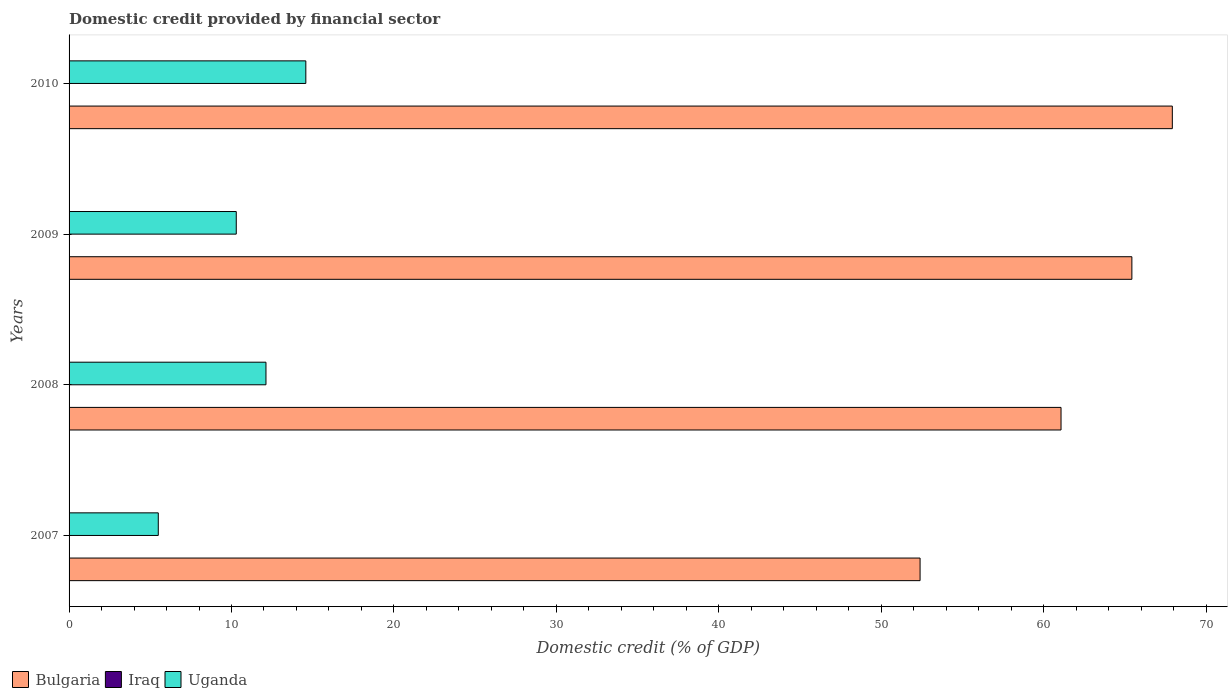How many different coloured bars are there?
Provide a short and direct response. 2. How many groups of bars are there?
Your answer should be compact. 4. Are the number of bars on each tick of the Y-axis equal?
Your response must be concise. Yes. What is the domestic credit in Iraq in 2009?
Ensure brevity in your answer.  0. Across all years, what is the maximum domestic credit in Bulgaria?
Offer a terse response. 67.92. Across all years, what is the minimum domestic credit in Uganda?
Offer a terse response. 5.49. In which year was the domestic credit in Bulgaria maximum?
Keep it short and to the point. 2010. What is the total domestic credit in Bulgaria in the graph?
Offer a terse response. 246.82. What is the difference between the domestic credit in Bulgaria in 2008 and that in 2009?
Keep it short and to the point. -4.36. What is the difference between the domestic credit in Uganda in 2010 and the domestic credit in Iraq in 2007?
Offer a terse response. 14.58. In the year 2009, what is the difference between the domestic credit in Uganda and domestic credit in Bulgaria?
Provide a succinct answer. -55.14. What is the ratio of the domestic credit in Uganda in 2008 to that in 2009?
Ensure brevity in your answer.  1.18. Is the domestic credit in Bulgaria in 2007 less than that in 2008?
Provide a short and direct response. Yes. Is the difference between the domestic credit in Uganda in 2007 and 2010 greater than the difference between the domestic credit in Bulgaria in 2007 and 2010?
Offer a terse response. Yes. What is the difference between the highest and the second highest domestic credit in Bulgaria?
Your answer should be compact. 2.49. What is the difference between the highest and the lowest domestic credit in Uganda?
Your answer should be very brief. 9.08. How many bars are there?
Your answer should be very brief. 8. How many years are there in the graph?
Ensure brevity in your answer.  4. Are the values on the major ticks of X-axis written in scientific E-notation?
Offer a terse response. No. Does the graph contain any zero values?
Make the answer very short. Yes. How many legend labels are there?
Your response must be concise. 3. What is the title of the graph?
Offer a terse response. Domestic credit provided by financial sector. Does "Qatar" appear as one of the legend labels in the graph?
Your response must be concise. No. What is the label or title of the X-axis?
Provide a short and direct response. Domestic credit (% of GDP). What is the label or title of the Y-axis?
Your response must be concise. Years. What is the Domestic credit (% of GDP) in Bulgaria in 2007?
Offer a terse response. 52.39. What is the Domestic credit (% of GDP) of Iraq in 2007?
Offer a very short reply. 0. What is the Domestic credit (% of GDP) in Uganda in 2007?
Provide a short and direct response. 5.49. What is the Domestic credit (% of GDP) in Bulgaria in 2008?
Your response must be concise. 61.07. What is the Domestic credit (% of GDP) in Uganda in 2008?
Keep it short and to the point. 12.12. What is the Domestic credit (% of GDP) of Bulgaria in 2009?
Offer a terse response. 65.43. What is the Domestic credit (% of GDP) in Iraq in 2009?
Your response must be concise. 0. What is the Domestic credit (% of GDP) of Uganda in 2009?
Offer a very short reply. 10.29. What is the Domestic credit (% of GDP) in Bulgaria in 2010?
Offer a very short reply. 67.92. What is the Domestic credit (% of GDP) of Uganda in 2010?
Make the answer very short. 14.58. Across all years, what is the maximum Domestic credit (% of GDP) in Bulgaria?
Your answer should be compact. 67.92. Across all years, what is the maximum Domestic credit (% of GDP) of Uganda?
Make the answer very short. 14.58. Across all years, what is the minimum Domestic credit (% of GDP) in Bulgaria?
Provide a succinct answer. 52.39. Across all years, what is the minimum Domestic credit (% of GDP) in Uganda?
Ensure brevity in your answer.  5.49. What is the total Domestic credit (% of GDP) of Bulgaria in the graph?
Your response must be concise. 246.82. What is the total Domestic credit (% of GDP) in Uganda in the graph?
Your answer should be very brief. 42.48. What is the difference between the Domestic credit (% of GDP) in Bulgaria in 2007 and that in 2008?
Keep it short and to the point. -8.68. What is the difference between the Domestic credit (% of GDP) in Uganda in 2007 and that in 2008?
Ensure brevity in your answer.  -6.63. What is the difference between the Domestic credit (% of GDP) of Bulgaria in 2007 and that in 2009?
Your answer should be compact. -13.04. What is the difference between the Domestic credit (% of GDP) of Uganda in 2007 and that in 2009?
Offer a terse response. -4.8. What is the difference between the Domestic credit (% of GDP) in Bulgaria in 2007 and that in 2010?
Provide a short and direct response. -15.53. What is the difference between the Domestic credit (% of GDP) of Uganda in 2007 and that in 2010?
Give a very brief answer. -9.08. What is the difference between the Domestic credit (% of GDP) in Bulgaria in 2008 and that in 2009?
Your response must be concise. -4.36. What is the difference between the Domestic credit (% of GDP) of Uganda in 2008 and that in 2009?
Ensure brevity in your answer.  1.83. What is the difference between the Domestic credit (% of GDP) in Bulgaria in 2008 and that in 2010?
Your response must be concise. -6.85. What is the difference between the Domestic credit (% of GDP) in Uganda in 2008 and that in 2010?
Keep it short and to the point. -2.45. What is the difference between the Domestic credit (% of GDP) in Bulgaria in 2009 and that in 2010?
Keep it short and to the point. -2.49. What is the difference between the Domestic credit (% of GDP) in Uganda in 2009 and that in 2010?
Give a very brief answer. -4.28. What is the difference between the Domestic credit (% of GDP) of Bulgaria in 2007 and the Domestic credit (% of GDP) of Uganda in 2008?
Provide a short and direct response. 40.27. What is the difference between the Domestic credit (% of GDP) in Bulgaria in 2007 and the Domestic credit (% of GDP) in Uganda in 2009?
Ensure brevity in your answer.  42.1. What is the difference between the Domestic credit (% of GDP) in Bulgaria in 2007 and the Domestic credit (% of GDP) in Uganda in 2010?
Your answer should be very brief. 37.82. What is the difference between the Domestic credit (% of GDP) in Bulgaria in 2008 and the Domestic credit (% of GDP) in Uganda in 2009?
Make the answer very short. 50.78. What is the difference between the Domestic credit (% of GDP) in Bulgaria in 2008 and the Domestic credit (% of GDP) in Uganda in 2010?
Ensure brevity in your answer.  46.49. What is the difference between the Domestic credit (% of GDP) in Bulgaria in 2009 and the Domestic credit (% of GDP) in Uganda in 2010?
Keep it short and to the point. 50.86. What is the average Domestic credit (% of GDP) in Bulgaria per year?
Offer a terse response. 61.7. What is the average Domestic credit (% of GDP) in Iraq per year?
Your answer should be very brief. 0. What is the average Domestic credit (% of GDP) of Uganda per year?
Offer a very short reply. 10.62. In the year 2007, what is the difference between the Domestic credit (% of GDP) of Bulgaria and Domestic credit (% of GDP) of Uganda?
Offer a terse response. 46.9. In the year 2008, what is the difference between the Domestic credit (% of GDP) of Bulgaria and Domestic credit (% of GDP) of Uganda?
Your answer should be very brief. 48.95. In the year 2009, what is the difference between the Domestic credit (% of GDP) of Bulgaria and Domestic credit (% of GDP) of Uganda?
Make the answer very short. 55.14. In the year 2010, what is the difference between the Domestic credit (% of GDP) of Bulgaria and Domestic credit (% of GDP) of Uganda?
Your response must be concise. 53.35. What is the ratio of the Domestic credit (% of GDP) of Bulgaria in 2007 to that in 2008?
Provide a succinct answer. 0.86. What is the ratio of the Domestic credit (% of GDP) of Uganda in 2007 to that in 2008?
Offer a very short reply. 0.45. What is the ratio of the Domestic credit (% of GDP) in Bulgaria in 2007 to that in 2009?
Keep it short and to the point. 0.8. What is the ratio of the Domestic credit (% of GDP) of Uganda in 2007 to that in 2009?
Make the answer very short. 0.53. What is the ratio of the Domestic credit (% of GDP) of Bulgaria in 2007 to that in 2010?
Ensure brevity in your answer.  0.77. What is the ratio of the Domestic credit (% of GDP) in Uganda in 2007 to that in 2010?
Ensure brevity in your answer.  0.38. What is the ratio of the Domestic credit (% of GDP) in Bulgaria in 2008 to that in 2009?
Keep it short and to the point. 0.93. What is the ratio of the Domestic credit (% of GDP) of Uganda in 2008 to that in 2009?
Provide a succinct answer. 1.18. What is the ratio of the Domestic credit (% of GDP) of Bulgaria in 2008 to that in 2010?
Offer a terse response. 0.9. What is the ratio of the Domestic credit (% of GDP) of Uganda in 2008 to that in 2010?
Offer a very short reply. 0.83. What is the ratio of the Domestic credit (% of GDP) of Bulgaria in 2009 to that in 2010?
Offer a terse response. 0.96. What is the ratio of the Domestic credit (% of GDP) in Uganda in 2009 to that in 2010?
Your response must be concise. 0.71. What is the difference between the highest and the second highest Domestic credit (% of GDP) in Bulgaria?
Provide a succinct answer. 2.49. What is the difference between the highest and the second highest Domestic credit (% of GDP) in Uganda?
Make the answer very short. 2.45. What is the difference between the highest and the lowest Domestic credit (% of GDP) in Bulgaria?
Your answer should be compact. 15.53. What is the difference between the highest and the lowest Domestic credit (% of GDP) in Uganda?
Offer a very short reply. 9.08. 